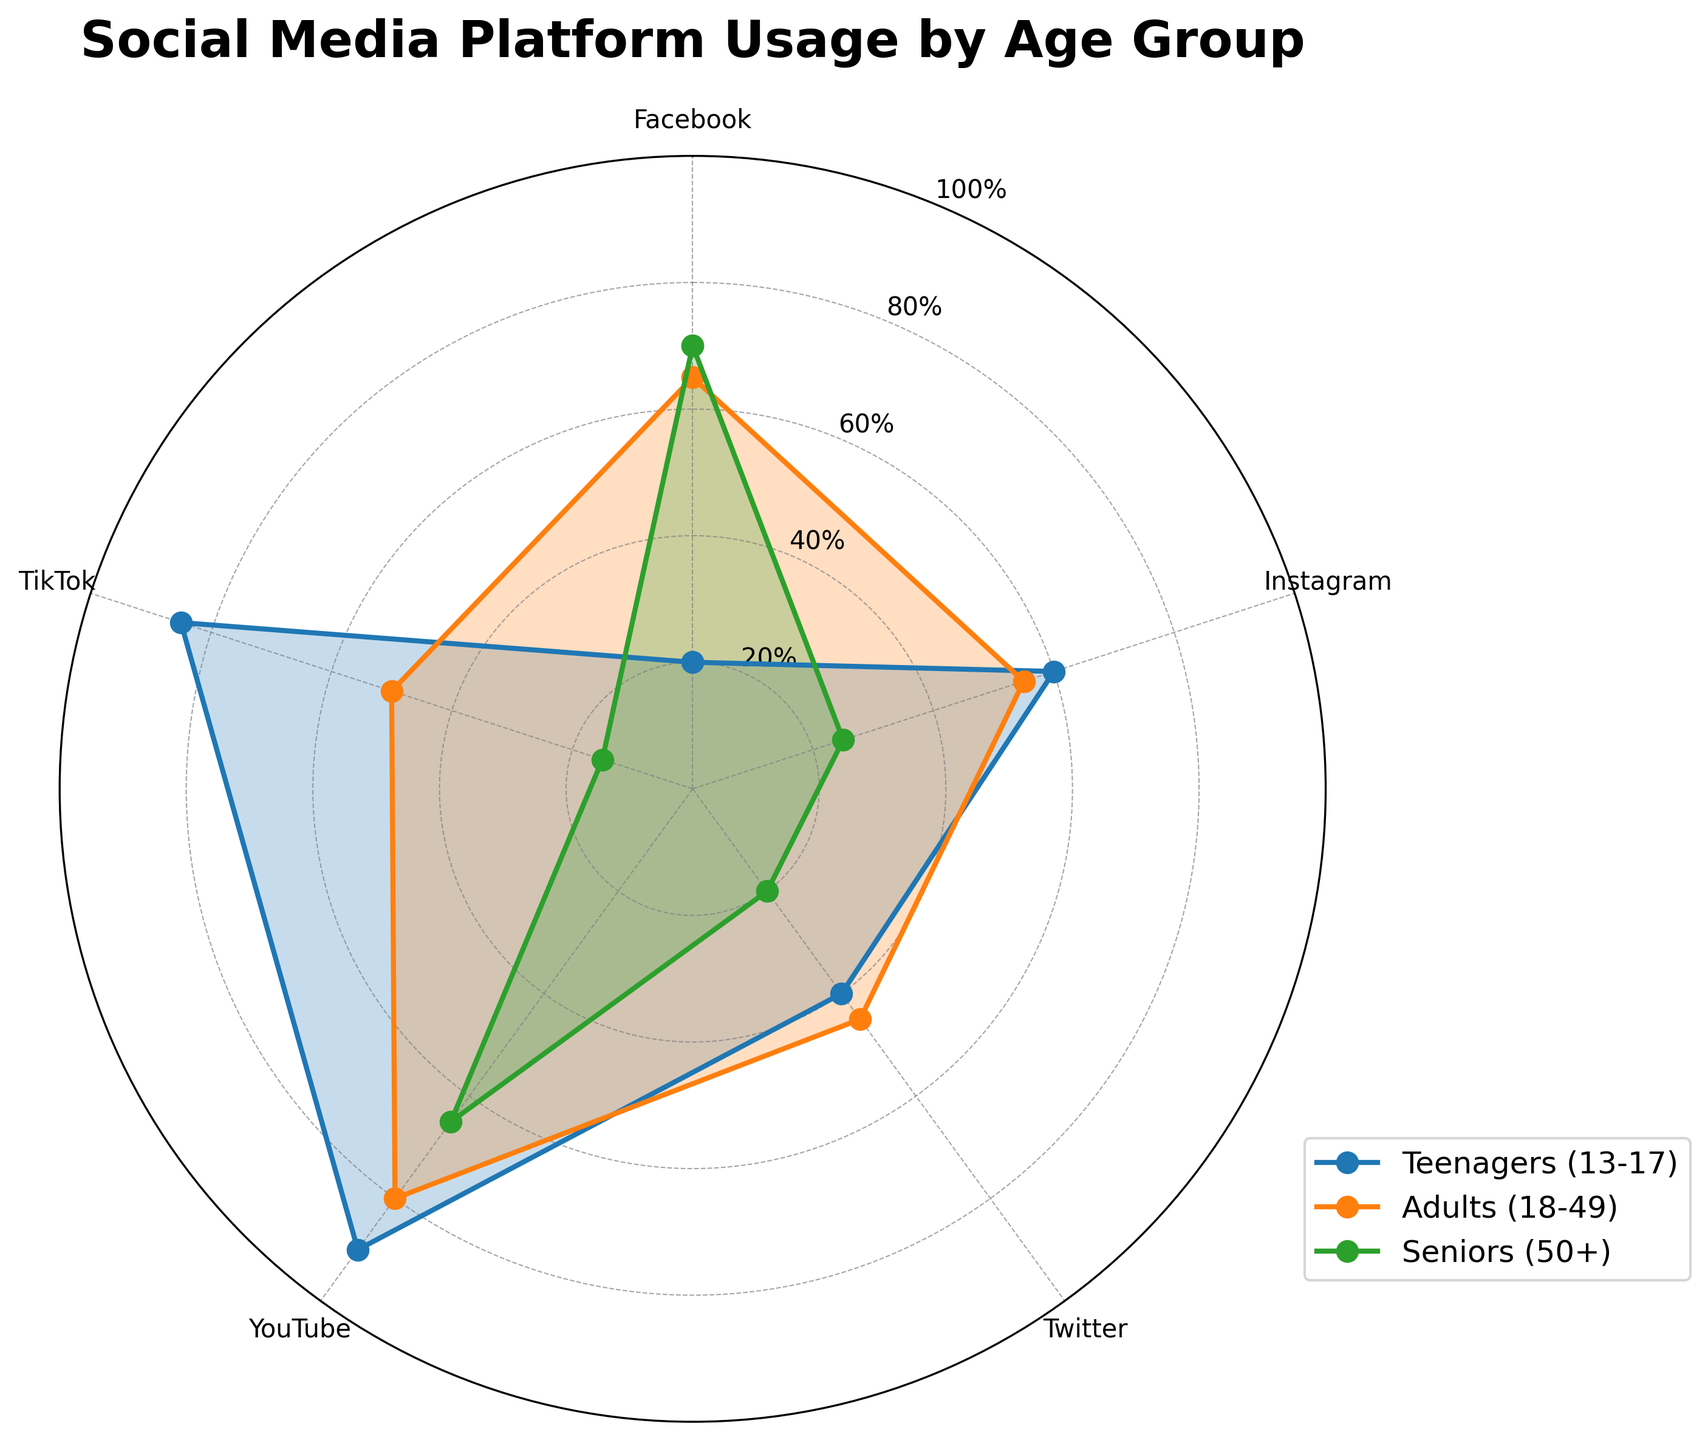What's the title of the chart? The title of the chart is located at the top and is typically in larger and bolder text than other elements for prominence. Here, it states 'Social Media Platform Usage by Age Group'.
Answer: Social Media Platform Usage by Age Group Which age group has the highest YouTube usage? To find which age group has the highest YouTube usage, look at the points corresponding to YouTube on the radar chart. Teenagers (90), Adults (80), and Seniors (65). Teenagers have the highest value.
Answer: Teenagers What is the average Facebook usage across all age groups? To find the average, sum the Facebook usage values for all age groups (20 + 65 + 70) = 155 and divide by the number of age groups (3). The average is 155/3 = 51.67.
Answer: 51.67 Is there any social media platform where Teenagers have the lowest usage compared to other age groups? For each platform (Facebook, Instagram, Twitter, YouTube, TikTok), check if the value for Teenagers is the smallest. Facebook (20), Instagram (60), Twitter (40), YouTube (90), TikTok (85). Teenagers have the lowest usage only for Facebook.
Answer: Facebook Which social media platform shows the largest difference in usage between Teenagers and Seniors? Calculate the usage difference between Teenagers and Seniors for each platform: Facebook (50), Instagram (35), Twitter (20), YouTube (25), TikTok (70). The largest difference is for TikTok.
Answer: TikTok Compare the YouTube usage between Adults and Seniors. Which age group uses it more? Look at the figures for YouTube usage: Adults (80) and Seniors (65). Adults use it more than Seniors.
Answer: Adults What is the total usage percentage for Twitter across all age groups? Sum the values for Twitter usage: Teenagers (40), Adults (45), Seniors (20). The total is 40 + 45 + 20 = 105.
Answer: 105 Which two platforms have the closest usage percentages among Adults? Compare the usage values for Adults: Facebook (65), Instagram (55), Twitter (45), YouTube (80), TikTok (50). The closest percentages are for Instagram (55) and TikTok (50), with a difference of 5%.
Answer: Instagram and TikTok On which platform do Seniors have the least presence? Identify the smallest value in Seniors' data: Facebook (70), Instagram (25), Twitter (20), YouTube (65), TikTok (15). TikTok has the smallest value.
Answer: TikTok Between which two platforms is usage among Teenagers most similar? Compare the usage values among Teenagers: Facebook (20), Instagram (60), Twitter (40), YouTube (90), TikTok (85). Twitter (40) and Instagram (60) are the closest, with a difference of 20%.
Answer: Twitter and Instagram 